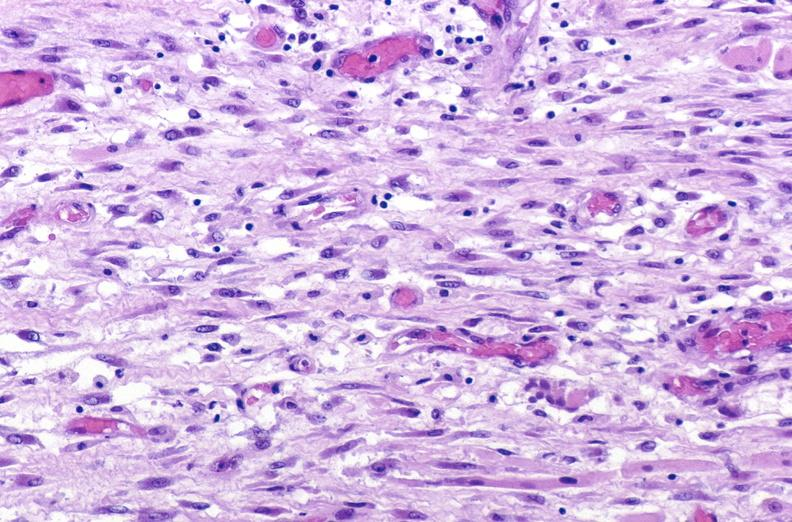s hypospadias present?
Answer the question using a single word or phrase. No 